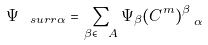<formula> <loc_0><loc_0><loc_500><loc_500>\Psi _ { \ s u r r { \alpha } } = \sum _ { \beta \in \ A } \Psi _ { \beta } ( C ^ { m } ) ^ { \beta } _ { \ \alpha }</formula> 